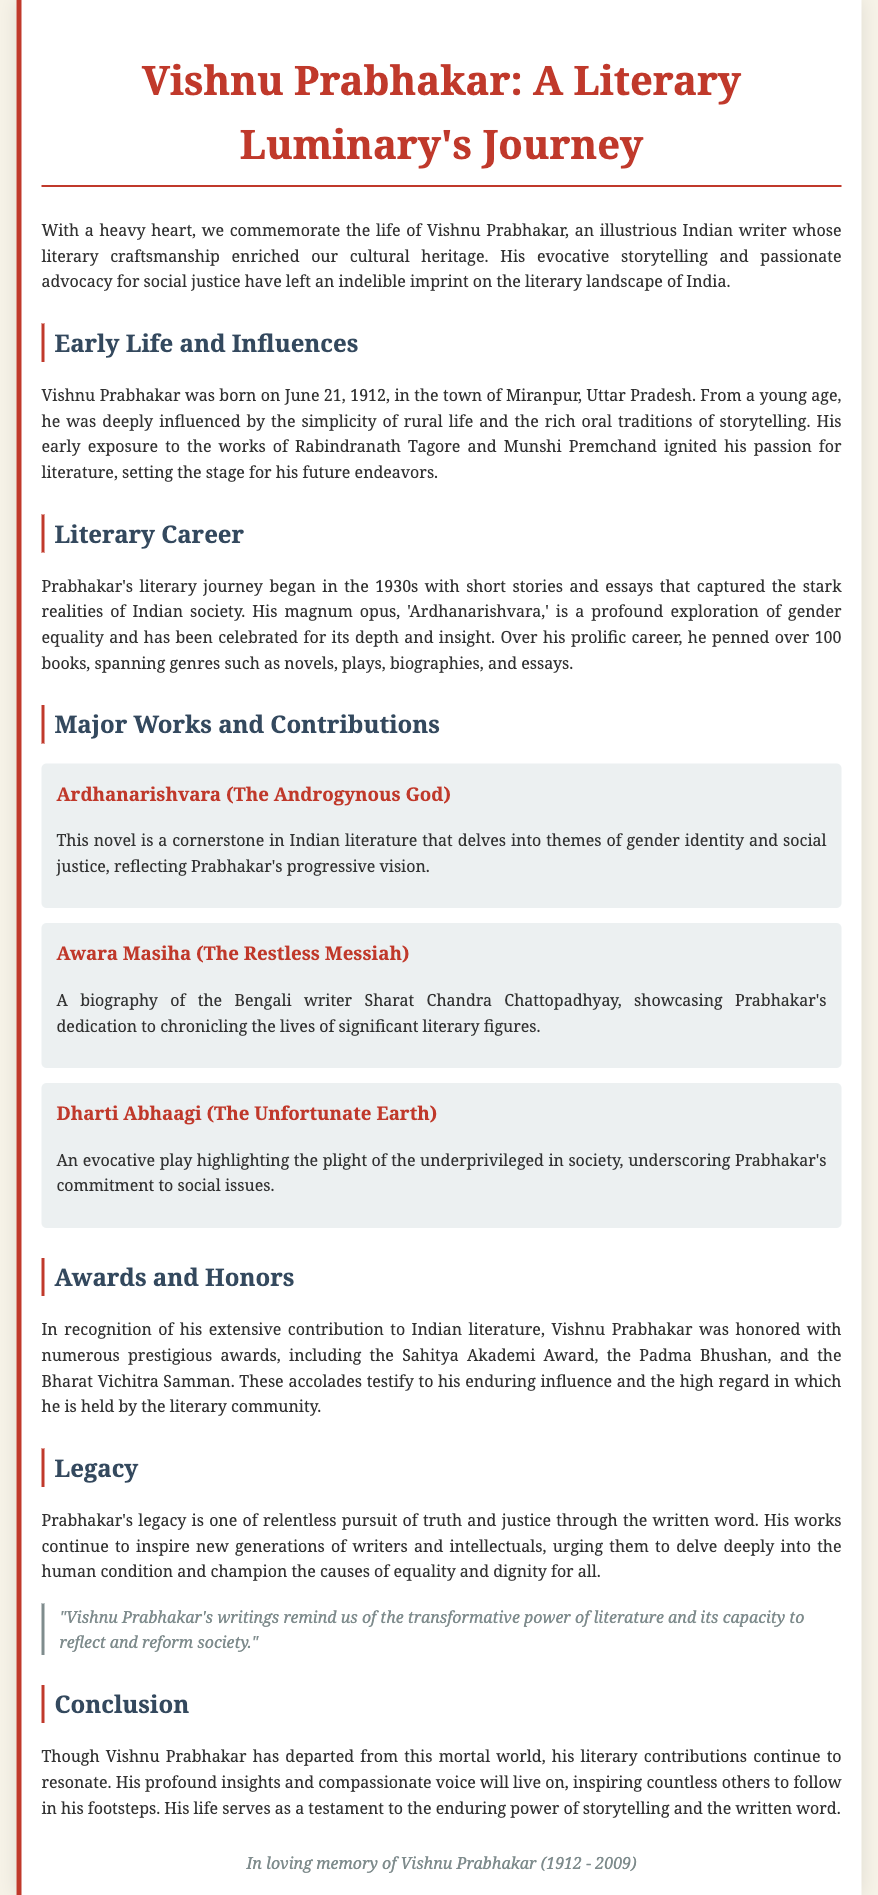What is the birth date of Vishnu Prabhakar? The document states Vishnu Prabhakar was born on June 21, 1912.
Answer: June 21, 1912 What is the title of Vishnu Prabhakar's magnum opus? The document mentions 'Ardhanarishvara' as Prabhakar's magnum opus.
Answer: Ardhanarishvara Which prestigious award did he receive? The document lists the Padma Bhushan as one of the accolades received by Vishnu Prabhakar.
Answer: Padma Bhushan What is the focus of the play "Dharti Abhaagi"? The document describes the play as highlighting the plight of the underprivileged in society.
Answer: Plight of the underprivileged What themes are explored in "Ardhanarishvara"? According to the document, "Ardhanarishvara" delves into themes of gender identity and social justice.
Answer: Gender identity and social justice What was the profession of Vishnu Prabhakar? The document categorizes him as an Indian writer, emphasizing his literary craftsmanship.
Answer: Writer What did Vishnu Prabhakar's writings urge new generations to pursue? The document notes that his works inspire new generations to champion equality and dignity for all.
Answer: Equality and dignity How many books did Prabhakar pen during his career? The document states that he penned over 100 books throughout his prolific career.
Answer: Over 100 books What is the tone conveyed in the conclusion of the obituary? The conclusion reflects a tone of remembrance and reverence for Vishnu Prabhakar's contributions.
Answer: Remembrance and reverence 